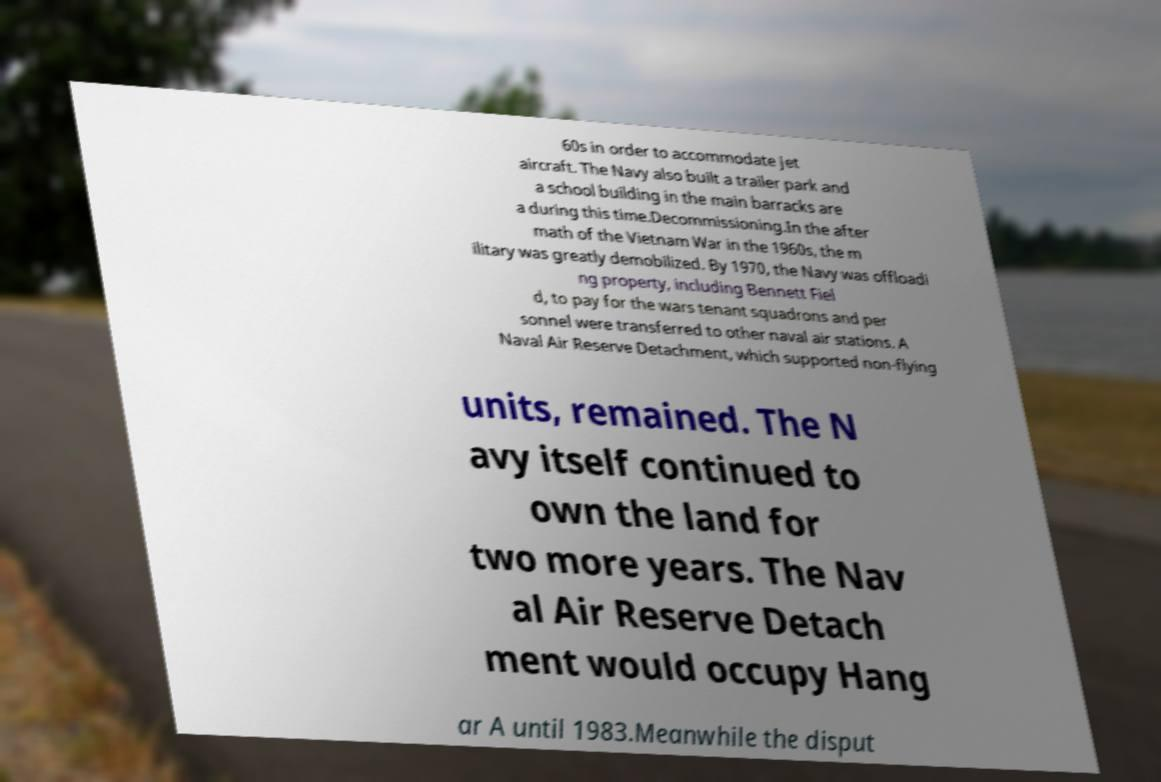What messages or text are displayed in this image? I need them in a readable, typed format. 60s in order to accommodate jet aircraft. The Navy also built a trailer park and a school building in the main barracks are a during this time.Decommissioning.In the after math of the Vietnam War in the 1960s, the m ilitary was greatly demobilized. By 1970, the Navy was offloadi ng property, including Bennett Fiel d, to pay for the wars tenant squadrons and per sonnel were transferred to other naval air stations. A Naval Air Reserve Detachment, which supported non-flying units, remained. The N avy itself continued to own the land for two more years. The Nav al Air Reserve Detach ment would occupy Hang ar A until 1983.Meanwhile the disput 